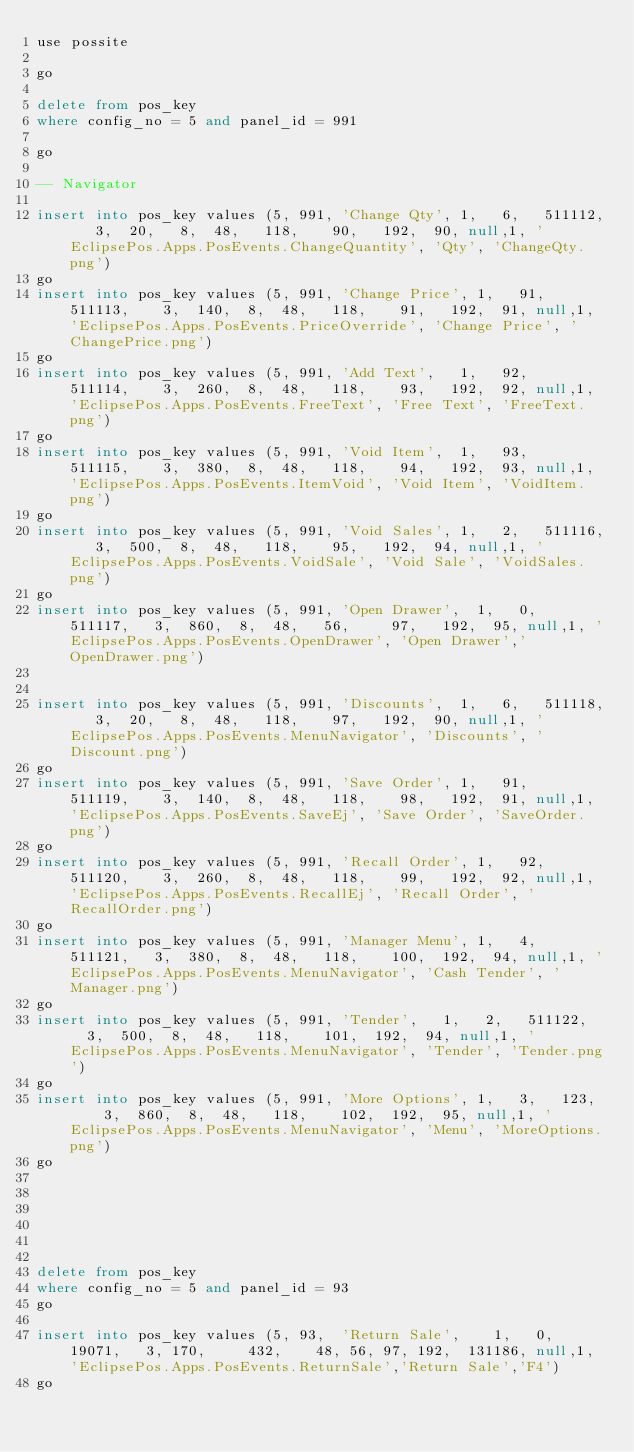<code> <loc_0><loc_0><loc_500><loc_500><_SQL_>use possite

go 

delete from pos_key 
where config_no = 5 and panel_id = 991

go

-- Navigator

insert into pos_key values (5, 991,	'Change Qty',	1,   6,   511112,		3,	20,		8,	48,		118,		90,		192,	90,	null,1, 'EclipsePos.Apps.PosEvents.ChangeQuantity', 'Qty', 'ChangeQty.png')
go
insert into pos_key values (5, 991,	'Change Price',	1,   91,   511113,		3,	140,	8,  48,		118,		91,		192,	91,	null,1, 'EclipsePos.Apps.PosEvents.PriceOverride', 'Change Price', 'ChangePrice.png')
go
insert into pos_key values (5, 991,	'Add Text',		1,   92,   511114,		3,	260,	8,  48,		118,		93,		192,	92,	null,1, 'EclipsePos.Apps.PosEvents.FreeText', 'Free Text', 'FreeText.png')
go
insert into pos_key values (5, 991,	'Void Item',	1,   93,   511115,		3,	380,	8,  48,		118,		94,		192,	93,	null,1, 'EclipsePos.Apps.PosEvents.ItemVoid', 'Void Item', 'VoidItem.png')
go
insert into pos_key values (5, 991,	'Void Sales',	1,   2,   511116,		3,	500,	8,  48,		118,		95,		192,	94,	null,1, 'EclipsePos.Apps.PosEvents.VoidSale', 'Void Sale', 'VoidSales.png')
go
insert into pos_key values (5, 991,	'Open Drawer',	1,   0,   511117,		3,  860,	8,  48,		56,			97,		192,	95,	null,1, 'EclipsePos.Apps.PosEvents.OpenDrawer', 'Open Drawer','OpenDrawer.png')


insert into pos_key values (5, 991,	'Discounts',	1,   6,   511118,		3,	20,		8,	48,		118,		97,		192,	90,	null,1, 'EclipsePos.Apps.PosEvents.MenuNavigator', 'Discounts', 'Discount.png')
go
insert into pos_key values (5, 991,	'Save Order',	1,   91,   511119,		3,	140,	8,  48,		118,		98,		192,	91,	null,1, 'EclipsePos.Apps.PosEvents.SaveEj', 'Save Order', 'SaveOrder.png')
go
insert into pos_key values (5, 991,	'Recall Order',	1,   92,   511120,		3,	260,	8,  48,		118,		99,		192,	92,	null,1, 'EclipsePos.Apps.PosEvents.RecallEj', 'Recall Order', 'RecallOrder.png')
go
insert into pos_key values (5, 991,	'Manager Menu',	1,   4,   511121,		3,	380,	8,  48,		118,		100,	192,	94,	null,1, 'EclipsePos.Apps.PosEvents.MenuNavigator', 'Cash Tender', 'Manager.png')
go
insert into pos_key values (5, 991,	'Tender',		1,   2,   511122,		3,	500,	8,  48,		118,		101,	192,	94,	null,1, 'EclipsePos.Apps.PosEvents.MenuNavigator', 'Tender', 'Tender.png')
go
insert into pos_key values (5, 991,	'More Options',	1,   3,   123,		3,	860,	8,  48,		118,		102,	192,	95,	null,1, 'EclipsePos.Apps.PosEvents.MenuNavigator', 'Menu', 'MoreOptions.png')
go

		




delete from pos_key 
where config_no = 5 and panel_id = 93
go

insert into pos_key values (5, 93,	'Return Sale',		1,   0,  19071,		3, 170,			432,		48, 56, 97,	192,	131186,	null,1, 'EclipsePos.Apps.PosEvents.ReturnSale','Return Sale','F4')
go
</code> 